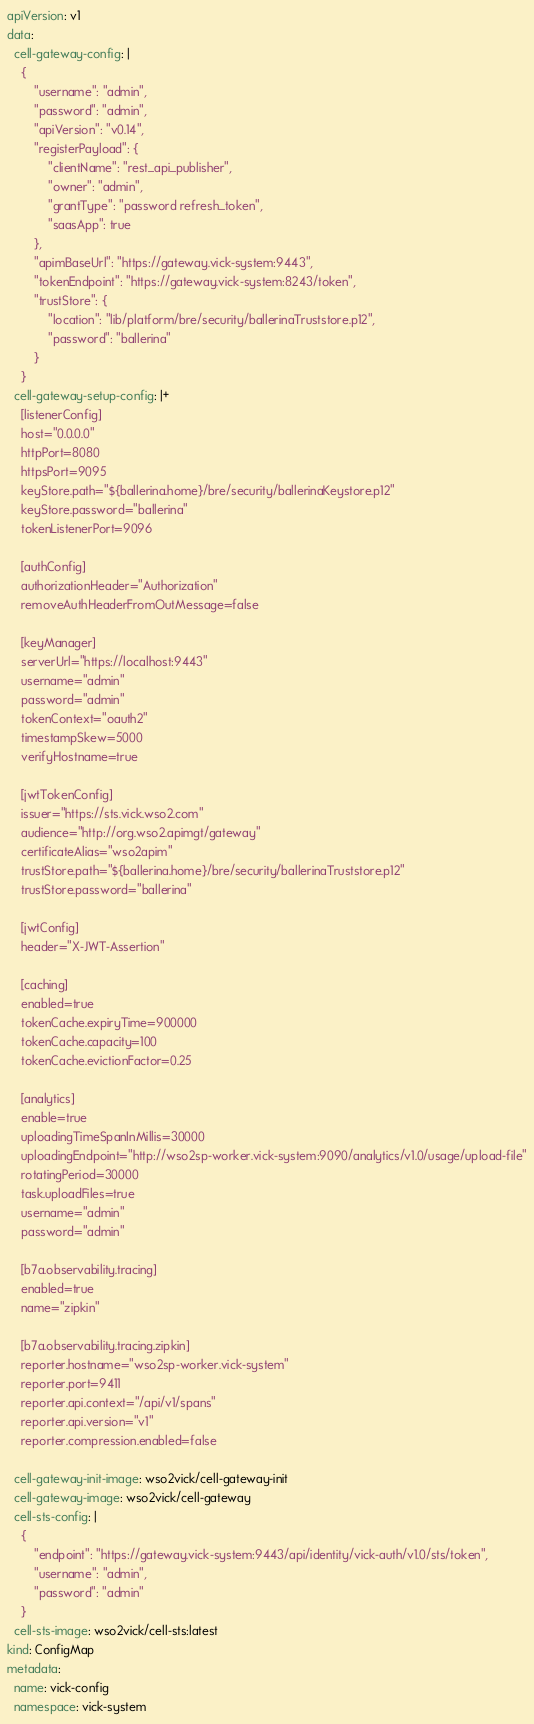Convert code to text. <code><loc_0><loc_0><loc_500><loc_500><_YAML_>apiVersion: v1
data:
  cell-gateway-config: |
    {
        "username": "admin",
        "password": "admin",
        "apiVersion": "v0.14",
        "registerPayload": {
            "clientName": "rest_api_publisher",
            "owner": "admin",
            "grantType": "password refresh_token",
            "saasApp": true
        },
        "apimBaseUrl": "https://gateway.vick-system:9443",
        "tokenEndpoint": "https://gateway.vick-system:8243/token",
        "trustStore": {
            "location": "lib/platform/bre/security/ballerinaTruststore.p12",
            "password": "ballerina"
        }
    }
  cell-gateway-setup-config: |+
    [listenerConfig]
    host="0.0.0.0"
    httpPort=8080
    httpsPort=9095
    keyStore.path="${ballerina.home}/bre/security/ballerinaKeystore.p12"
    keyStore.password="ballerina"
    tokenListenerPort=9096

    [authConfig]
    authorizationHeader="Authorization"
    removeAuthHeaderFromOutMessage=false

    [keyManager]
    serverUrl="https://localhost:9443"
    username="admin"
    password="admin"
    tokenContext="oauth2"
    timestampSkew=5000
    verifyHostname=true

    [jwtTokenConfig]
    issuer="https://sts.vick.wso2.com"
    audience="http://org.wso2.apimgt/gateway"
    certificateAlias="wso2apim"
    trustStore.path="${ballerina.home}/bre/security/ballerinaTruststore.p12"
    trustStore.password="ballerina"

    [jwtConfig]
    header="X-JWT-Assertion"

    [caching]
    enabled=true
    tokenCache.expiryTime=900000
    tokenCache.capacity=100
    tokenCache.evictionFactor=0.25

    [analytics]
    enable=true
    uploadingTimeSpanInMillis=30000
    uploadingEndpoint="http://wso2sp-worker.vick-system:9090/analytics/v1.0/usage/upload-file"
    rotatingPeriod=30000
    task.uploadFiles=true
    username="admin"
    password="admin"

    [b7a.observability.tracing]
    enabled=true
    name="zipkin"

    [b7a.observability.tracing.zipkin]
    reporter.hostname="wso2sp-worker.vick-system"
    reporter.port=9411
    reporter.api.context="/api/v1/spans"
    reporter.api.version="v1"
    reporter.compression.enabled=false

  cell-gateway-init-image: wso2vick/cell-gateway-init
  cell-gateway-image: wso2vick/cell-gateway
  cell-sts-config: |
    {
        "endpoint": "https://gateway.vick-system:9443/api/identity/vick-auth/v1.0/sts/token",
        "username": "admin",
        "password": "admin"
    }
  cell-sts-image: wso2vick/cell-sts:latest
kind: ConfigMap
metadata:
  name: vick-config
  namespace: vick-system
</code> 